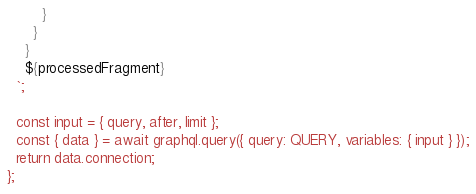<code> <loc_0><loc_0><loc_500><loc_500><_JavaScript_>        }
      }
    }
    ${processedFragment}
  `;

  const input = { query, after, limit };
  const { data } = await graphql.query({ query: QUERY, variables: { input } });
  return data.connection;
};
</code> 